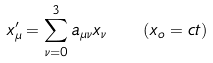<formula> <loc_0><loc_0><loc_500><loc_500>x _ { \mu } ^ { \prime } = \sum _ { \nu = 0 } ^ { 3 } a _ { \mu \nu } x _ { \nu } \quad ( x _ { o } = c t )</formula> 